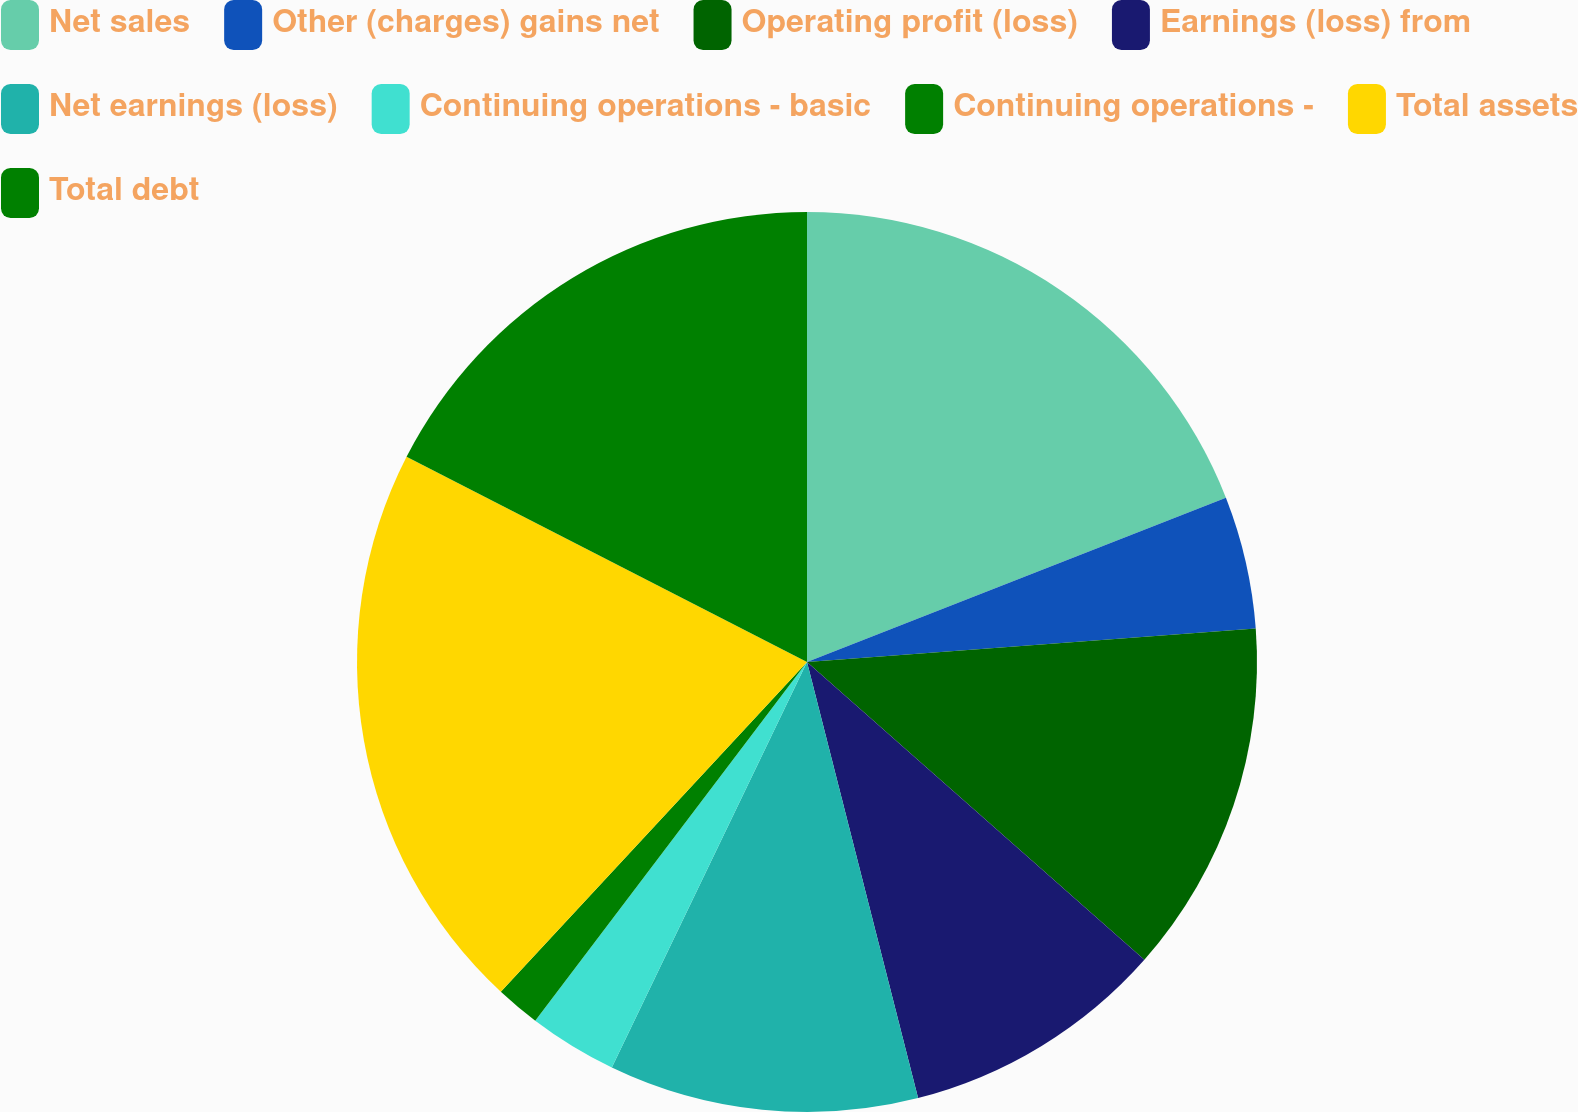Convert chart. <chart><loc_0><loc_0><loc_500><loc_500><pie_chart><fcel>Net sales<fcel>Other (charges) gains net<fcel>Operating profit (loss)<fcel>Earnings (loss) from<fcel>Net earnings (loss)<fcel>Continuing operations - basic<fcel>Continuing operations -<fcel>Total assets<fcel>Total debt<nl><fcel>19.05%<fcel>4.76%<fcel>12.7%<fcel>9.52%<fcel>11.11%<fcel>3.18%<fcel>1.59%<fcel>20.63%<fcel>17.46%<nl></chart> 